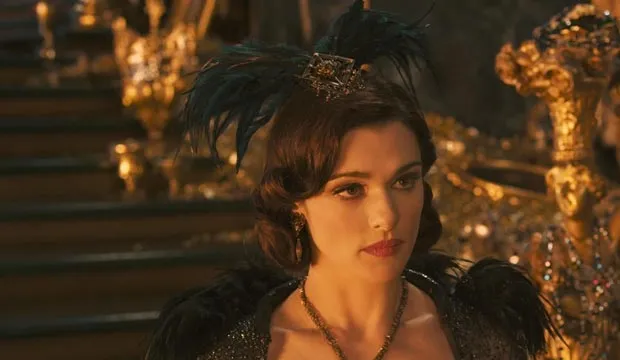Describe a scenario where Evanora shows a moment of vulnerability. In the quiet solitude of her private chambers, away from prying eyes, Evanora allows herself a rare moment of vulnerability. She stands before a mirror, her hardened exterior softening as she removes her elaborate headdress and gazes at her reflection. The weight of her ambitions and the cost of her power are etched on her face. Tears begin to well up in her eyes as she contemplates the sacrifices she has made and the loneliness that accompanies her relentless pursuit of control. 